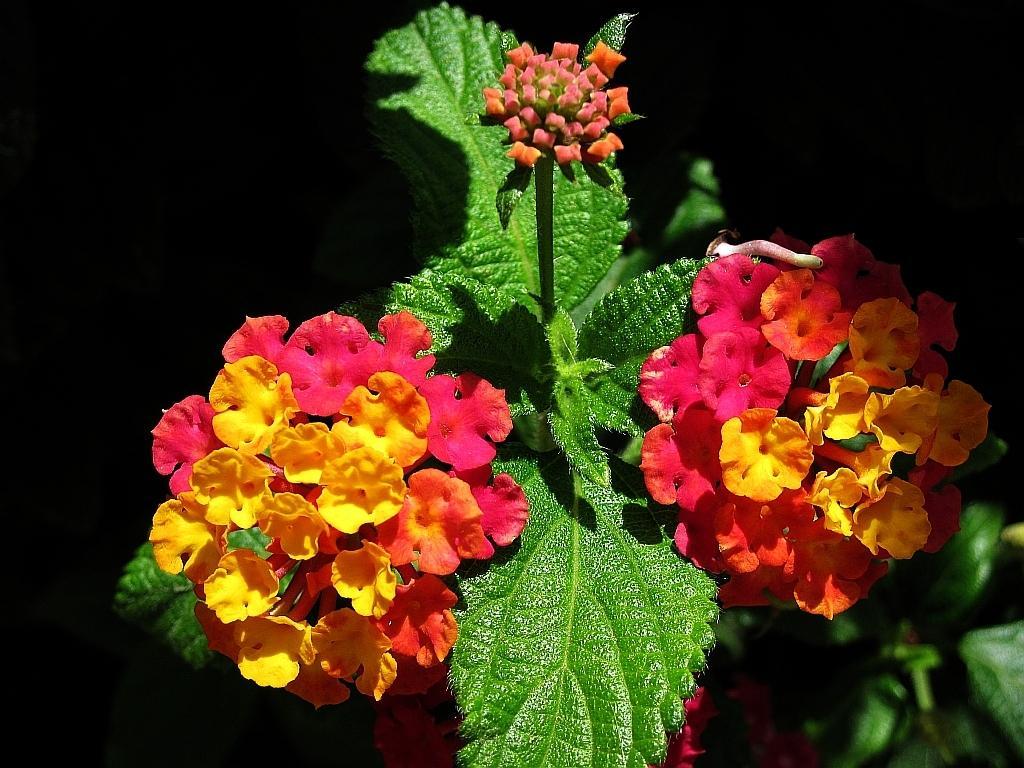Can you describe this image briefly? In this image there are colorful flowers and leaves. There is a black color background. 